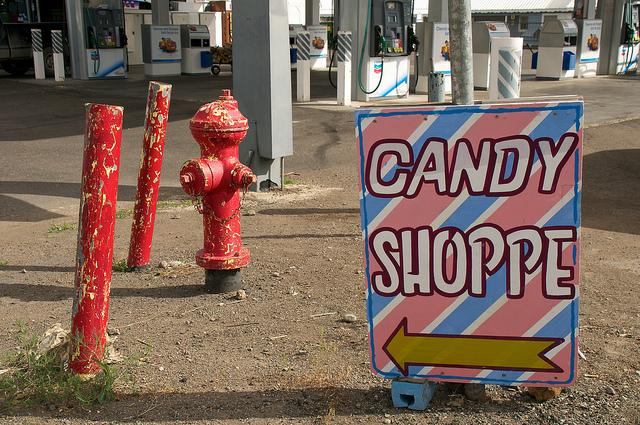What does the sign say?
Be succinct. Candy shoppe. Why is the sign near the dog in German?
Keep it brief. It's not. Is the ground wet?
Short answer required. No. What does the bus want you to do after you turn up?
Keep it brief. Nothing. What is the sign on?
Write a very short answer. Bricks. What is the arrow pointing to?
Give a very brief answer. Candy shoppe. 